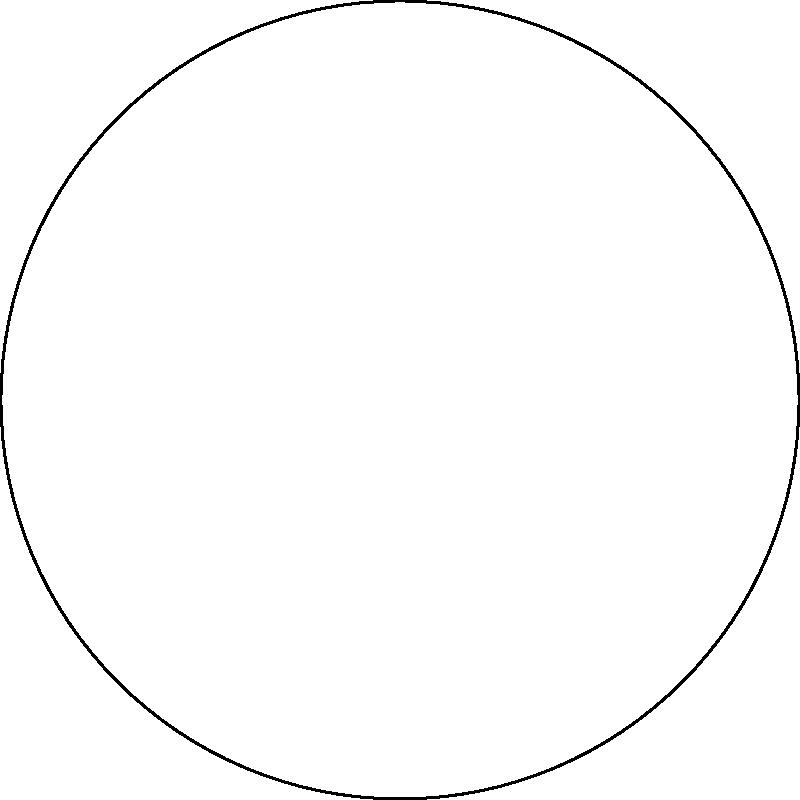In the Poincaré disk model of hyperbolic geometry shown above, points A and B are connected by a hyperbolic line (blue arc). If the Euclidean distance between A and the center O is 0.7071, and the Euclidean distance between B and O is 0.7616, what is the hyperbolic distance between A and B? Express your answer in terms of $\text{arccosh}$. To solve this problem, we'll follow these steps:

1) In the Poincaré disk model, the hyperbolic distance $d$ between two points $P_1=(x_1,y_1)$ and $P_2=(x_2,y_2)$ is given by:

   $$d = \text{arccosh}\left(1 + \frac{2|P_1-P_2|^2}{(1-|P_1|^2)(1-|P_2|^2)}\right)$$

   where $|P|$ denotes the Euclidean distance of point $P$ from the origin.

2) We're given that $|A| = 0.7071$ and $|B| = 0.7616$.

3) We need to find $|A-B|$, which is the Euclidean distance between A and B.

4) In a unit circle, if we know the coordinates of two points $(x_1,y_1)$ and $(x_2,y_2)$, we can calculate their Euclidean distance using:

   $$|A-B| = \sqrt{(x_2-x_1)^2 + (y_2-y_1)^2}$$

5) From the image, we can approximate:
   A ≈ (-0.5, 0.5)
   B ≈ (0.7, -0.3)

6) Plugging these into the distance formula:

   $$|A-B| = \sqrt{(0.7-(-0.5))^2 + (-0.3-0.5)^2} = \sqrt{1.2^2 + (-0.8)^2} = \sqrt{2.08} ≈ 1.4422$$

7) Now we have all the components to plug into the hyperbolic distance formula:

   $$d = \text{arccosh}\left(1 + \frac{2(1.4422)^2}{(1-0.7071^2)(1-0.7616^2)}\right)$$

8) Simplifying:

   $$d = \text{arccosh}\left(1 + \frac{4.1599}{(0.5000)(0.4200)}\right) = \text{arccosh}(20.7614)$$

This is the hyperbolic distance between A and B.
Answer: $\text{arccosh}(20.7614)$ 